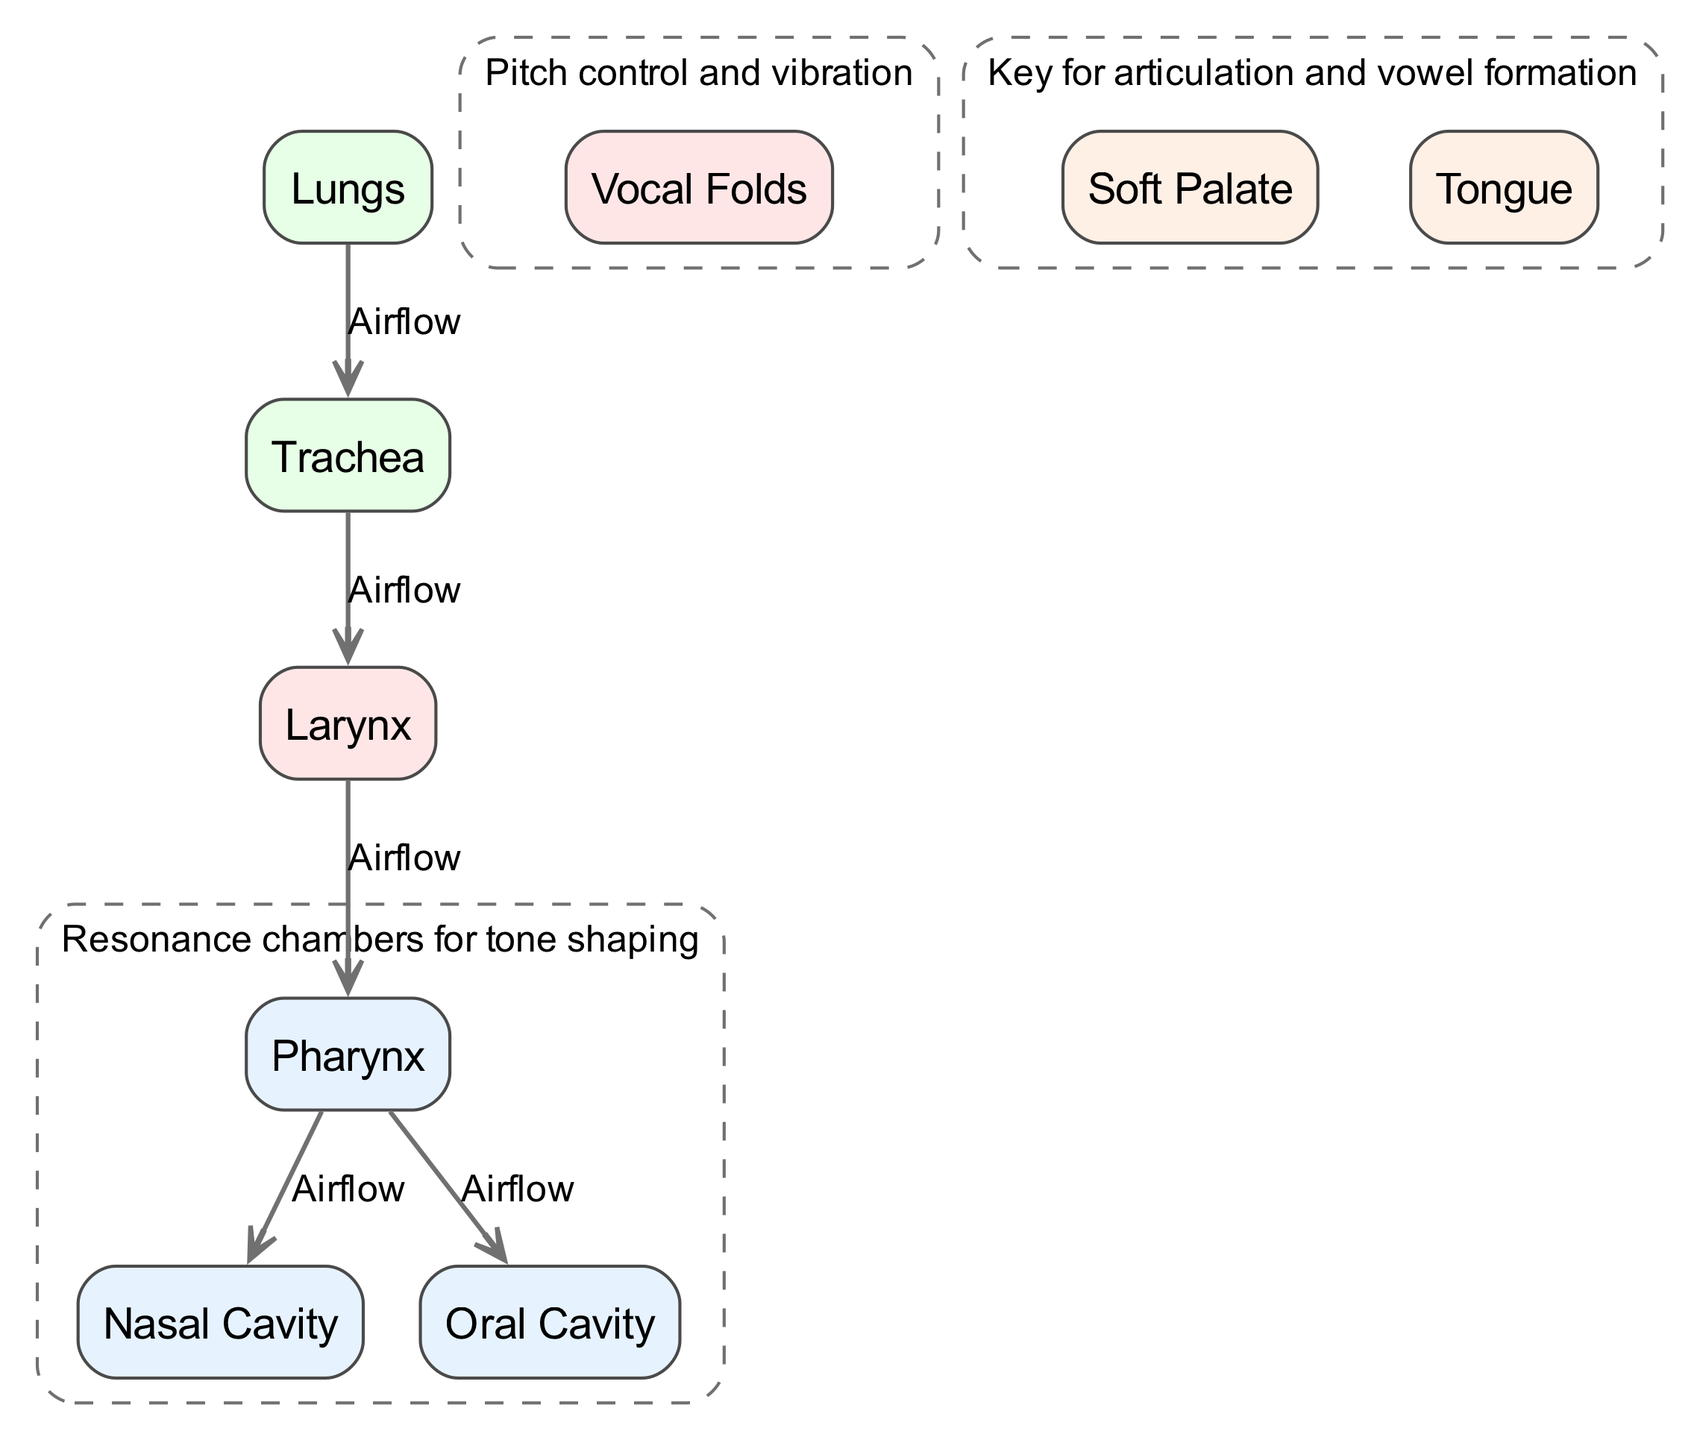What are the major chambers involved in resonance? The diagram indicates that the major chambers involved in resonance are the oral cavity, nasal cavity, and pharynx, as shown in the annotation connecting these nodes.
Answer: oral cavity, nasal cavity, pharynx What is the airflow direction from the trachea? The diagram shows that the airflow from the trachea moves to the larynx, indicating the direct pathway of airflow after the trachea.
Answer: larynx How many nodes are labeled in the diagram? By counting the nodes listed in the diagram, we see there are eight distinct labeled parts of the vocal tract anatomy.
Answer: 8 What part is responsible for pitch control? The diagram explicitly labels the vocal folds as the part responsible for pitch control, indicated by the annotation connecting to it.
Answer: vocal folds What are the two main paths that airflow can take after the pharynx? The edges from the pharynx show that airflow can move to both the oral cavity and the nasal cavity, highlighting the bifurcation of airflow direction at that point.
Answer: oral cavity, nasal cavity Which anatomical structure is located directly below the larynx? In the diagram, the larynx is shown to connect directly above the trachea, indicating that the trachea is the structure directly below the larynx.
Answer: trachea Which component aids in articulation? According to the diagram, both the tongue and the soft palate are noted to be key for articulation and vowel formation, as indicated by the annotation connecting them.
Answer: tongue, soft palate What part is indicated as the starting point for airflow? The diagram outlines the lungs as the starting point for airflow, depicted at the top of the airflow direction in the diagram.
Answer: lungs 